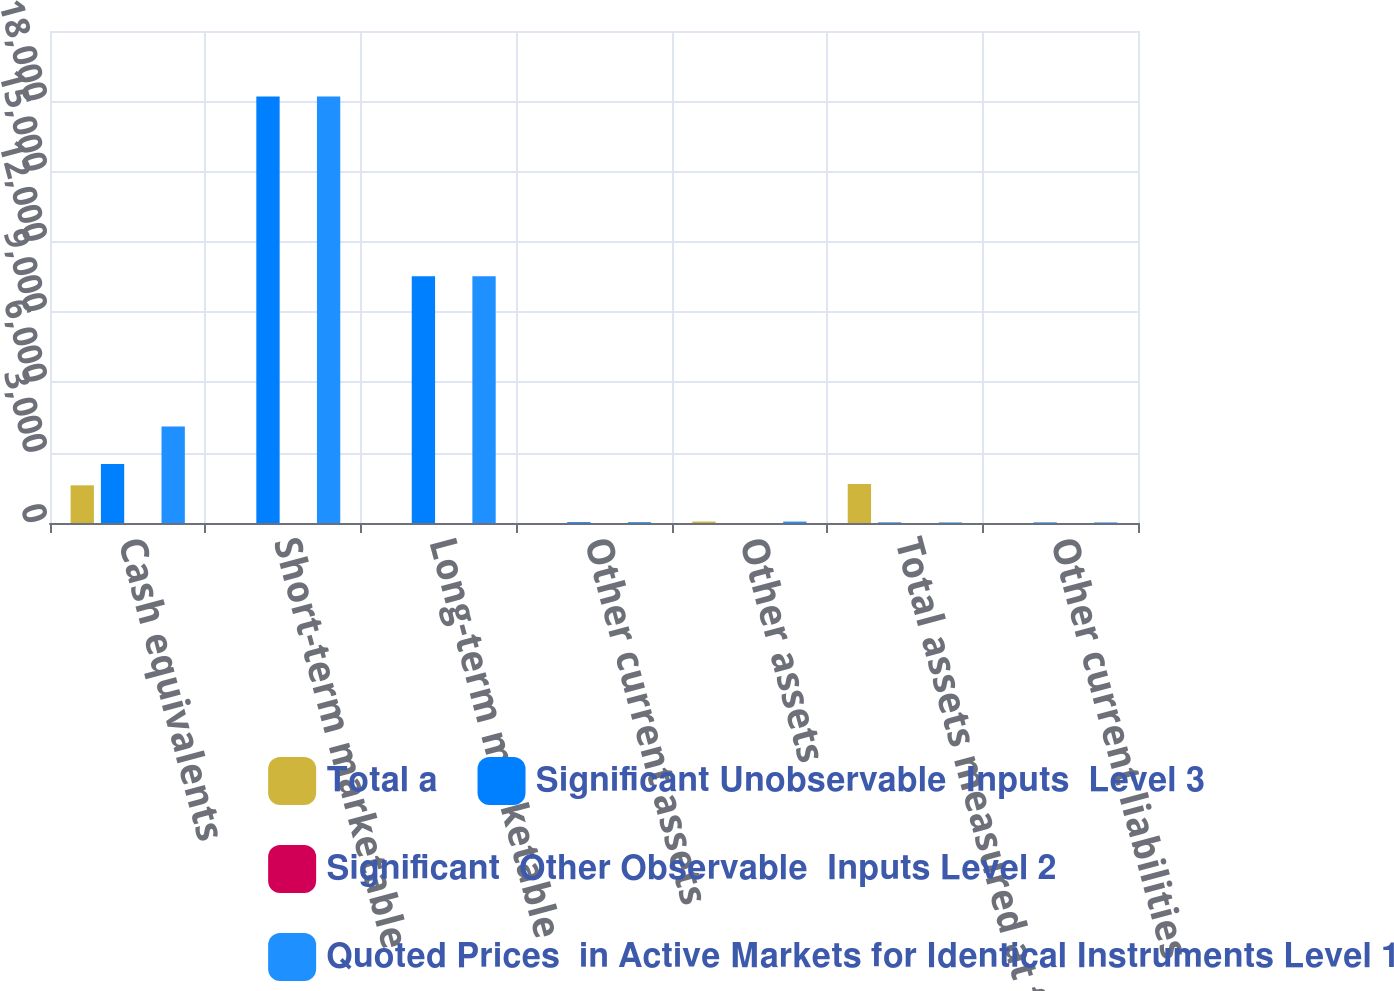Convert chart. <chart><loc_0><loc_0><loc_500><loc_500><stacked_bar_chart><ecel><fcel>Cash equivalents<fcel>Short-term marketable<fcel>Long-term marketable<fcel>Other current assets<fcel>Other assets<fcel>Total assets measured at fair<fcel>Other current liabilities<nl><fcel>Total a<fcel>1608<fcel>0<fcel>0<fcel>0<fcel>61<fcel>1669<fcel>0<nl><fcel>Significant Unobservable  Inputs  Level 3<fcel>2516<fcel>18201<fcel>10528<fcel>37<fcel>0<fcel>25<fcel>25<nl><fcel>Significant  Other Observable  Inputs Level 2<fcel>0<fcel>0<fcel>0<fcel>0<fcel>0<fcel>0<fcel>0<nl><fcel>Quoted Prices  in Active Markets for Identical Instruments Level 1<fcel>4124<fcel>18201<fcel>10528<fcel>37<fcel>61<fcel>25<fcel>25<nl></chart> 